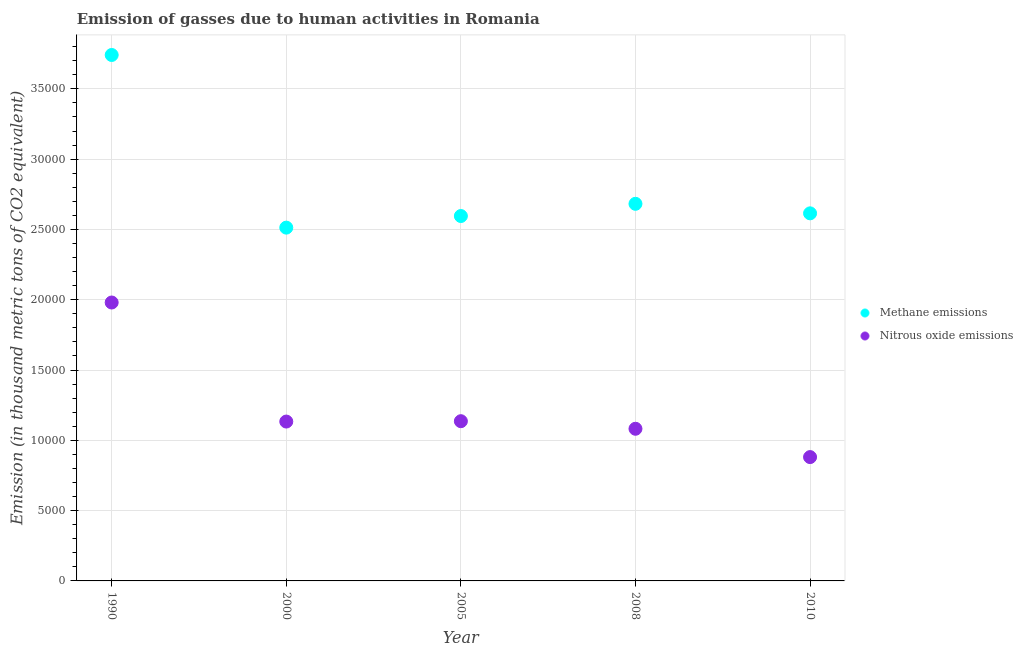Is the number of dotlines equal to the number of legend labels?
Offer a very short reply. Yes. What is the amount of methane emissions in 2010?
Your answer should be compact. 2.61e+04. Across all years, what is the maximum amount of methane emissions?
Provide a short and direct response. 3.74e+04. Across all years, what is the minimum amount of methane emissions?
Ensure brevity in your answer.  2.51e+04. In which year was the amount of nitrous oxide emissions maximum?
Provide a short and direct response. 1990. What is the total amount of nitrous oxide emissions in the graph?
Keep it short and to the point. 6.21e+04. What is the difference between the amount of methane emissions in 1990 and that in 2005?
Offer a very short reply. 1.15e+04. What is the difference between the amount of nitrous oxide emissions in 2010 and the amount of methane emissions in 2005?
Offer a very short reply. -1.71e+04. What is the average amount of nitrous oxide emissions per year?
Your answer should be compact. 1.24e+04. In the year 2000, what is the difference between the amount of methane emissions and amount of nitrous oxide emissions?
Provide a short and direct response. 1.38e+04. What is the ratio of the amount of methane emissions in 2005 to that in 2010?
Keep it short and to the point. 0.99. Is the difference between the amount of methane emissions in 2000 and 2005 greater than the difference between the amount of nitrous oxide emissions in 2000 and 2005?
Provide a succinct answer. No. What is the difference between the highest and the second highest amount of methane emissions?
Your answer should be compact. 1.06e+04. What is the difference between the highest and the lowest amount of methane emissions?
Ensure brevity in your answer.  1.23e+04. In how many years, is the amount of nitrous oxide emissions greater than the average amount of nitrous oxide emissions taken over all years?
Provide a short and direct response. 1. Is the amount of nitrous oxide emissions strictly less than the amount of methane emissions over the years?
Your answer should be very brief. Yes. How many years are there in the graph?
Your answer should be very brief. 5. What is the difference between two consecutive major ticks on the Y-axis?
Your answer should be very brief. 5000. Are the values on the major ticks of Y-axis written in scientific E-notation?
Keep it short and to the point. No. Does the graph contain any zero values?
Offer a terse response. No. Where does the legend appear in the graph?
Ensure brevity in your answer.  Center right. What is the title of the graph?
Your answer should be very brief. Emission of gasses due to human activities in Romania. Does "Public credit registry" appear as one of the legend labels in the graph?
Ensure brevity in your answer.  No. What is the label or title of the Y-axis?
Give a very brief answer. Emission (in thousand metric tons of CO2 equivalent). What is the Emission (in thousand metric tons of CO2 equivalent) of Methane emissions in 1990?
Your answer should be compact. 3.74e+04. What is the Emission (in thousand metric tons of CO2 equivalent) in Nitrous oxide emissions in 1990?
Offer a terse response. 1.98e+04. What is the Emission (in thousand metric tons of CO2 equivalent) of Methane emissions in 2000?
Make the answer very short. 2.51e+04. What is the Emission (in thousand metric tons of CO2 equivalent) in Nitrous oxide emissions in 2000?
Provide a succinct answer. 1.13e+04. What is the Emission (in thousand metric tons of CO2 equivalent) of Methane emissions in 2005?
Provide a short and direct response. 2.60e+04. What is the Emission (in thousand metric tons of CO2 equivalent) in Nitrous oxide emissions in 2005?
Give a very brief answer. 1.14e+04. What is the Emission (in thousand metric tons of CO2 equivalent) of Methane emissions in 2008?
Your answer should be very brief. 2.68e+04. What is the Emission (in thousand metric tons of CO2 equivalent) in Nitrous oxide emissions in 2008?
Offer a terse response. 1.08e+04. What is the Emission (in thousand metric tons of CO2 equivalent) in Methane emissions in 2010?
Your response must be concise. 2.61e+04. What is the Emission (in thousand metric tons of CO2 equivalent) in Nitrous oxide emissions in 2010?
Your answer should be very brief. 8808.3. Across all years, what is the maximum Emission (in thousand metric tons of CO2 equivalent) of Methane emissions?
Offer a terse response. 3.74e+04. Across all years, what is the maximum Emission (in thousand metric tons of CO2 equivalent) of Nitrous oxide emissions?
Give a very brief answer. 1.98e+04. Across all years, what is the minimum Emission (in thousand metric tons of CO2 equivalent) in Methane emissions?
Keep it short and to the point. 2.51e+04. Across all years, what is the minimum Emission (in thousand metric tons of CO2 equivalent) of Nitrous oxide emissions?
Provide a succinct answer. 8808.3. What is the total Emission (in thousand metric tons of CO2 equivalent) in Methane emissions in the graph?
Your response must be concise. 1.41e+05. What is the total Emission (in thousand metric tons of CO2 equivalent) in Nitrous oxide emissions in the graph?
Ensure brevity in your answer.  6.21e+04. What is the difference between the Emission (in thousand metric tons of CO2 equivalent) in Methane emissions in 1990 and that in 2000?
Ensure brevity in your answer.  1.23e+04. What is the difference between the Emission (in thousand metric tons of CO2 equivalent) in Nitrous oxide emissions in 1990 and that in 2000?
Keep it short and to the point. 8468. What is the difference between the Emission (in thousand metric tons of CO2 equivalent) in Methane emissions in 1990 and that in 2005?
Your answer should be very brief. 1.15e+04. What is the difference between the Emission (in thousand metric tons of CO2 equivalent) in Nitrous oxide emissions in 1990 and that in 2005?
Ensure brevity in your answer.  8442.4. What is the difference between the Emission (in thousand metric tons of CO2 equivalent) of Methane emissions in 1990 and that in 2008?
Offer a terse response. 1.06e+04. What is the difference between the Emission (in thousand metric tons of CO2 equivalent) of Nitrous oxide emissions in 1990 and that in 2008?
Ensure brevity in your answer.  8981.2. What is the difference between the Emission (in thousand metric tons of CO2 equivalent) in Methane emissions in 1990 and that in 2010?
Your answer should be compact. 1.13e+04. What is the difference between the Emission (in thousand metric tons of CO2 equivalent) in Nitrous oxide emissions in 1990 and that in 2010?
Make the answer very short. 1.10e+04. What is the difference between the Emission (in thousand metric tons of CO2 equivalent) in Methane emissions in 2000 and that in 2005?
Provide a short and direct response. -826. What is the difference between the Emission (in thousand metric tons of CO2 equivalent) in Nitrous oxide emissions in 2000 and that in 2005?
Give a very brief answer. -25.6. What is the difference between the Emission (in thousand metric tons of CO2 equivalent) of Methane emissions in 2000 and that in 2008?
Your response must be concise. -1694.4. What is the difference between the Emission (in thousand metric tons of CO2 equivalent) in Nitrous oxide emissions in 2000 and that in 2008?
Your answer should be very brief. 513.2. What is the difference between the Emission (in thousand metric tons of CO2 equivalent) in Methane emissions in 2000 and that in 2010?
Ensure brevity in your answer.  -1016.6. What is the difference between the Emission (in thousand metric tons of CO2 equivalent) in Nitrous oxide emissions in 2000 and that in 2010?
Provide a short and direct response. 2527.5. What is the difference between the Emission (in thousand metric tons of CO2 equivalent) in Methane emissions in 2005 and that in 2008?
Make the answer very short. -868.4. What is the difference between the Emission (in thousand metric tons of CO2 equivalent) of Nitrous oxide emissions in 2005 and that in 2008?
Your answer should be very brief. 538.8. What is the difference between the Emission (in thousand metric tons of CO2 equivalent) in Methane emissions in 2005 and that in 2010?
Provide a succinct answer. -190.6. What is the difference between the Emission (in thousand metric tons of CO2 equivalent) in Nitrous oxide emissions in 2005 and that in 2010?
Provide a short and direct response. 2553.1. What is the difference between the Emission (in thousand metric tons of CO2 equivalent) in Methane emissions in 2008 and that in 2010?
Provide a short and direct response. 677.8. What is the difference between the Emission (in thousand metric tons of CO2 equivalent) of Nitrous oxide emissions in 2008 and that in 2010?
Ensure brevity in your answer.  2014.3. What is the difference between the Emission (in thousand metric tons of CO2 equivalent) in Methane emissions in 1990 and the Emission (in thousand metric tons of CO2 equivalent) in Nitrous oxide emissions in 2000?
Make the answer very short. 2.61e+04. What is the difference between the Emission (in thousand metric tons of CO2 equivalent) of Methane emissions in 1990 and the Emission (in thousand metric tons of CO2 equivalent) of Nitrous oxide emissions in 2005?
Provide a succinct answer. 2.60e+04. What is the difference between the Emission (in thousand metric tons of CO2 equivalent) in Methane emissions in 1990 and the Emission (in thousand metric tons of CO2 equivalent) in Nitrous oxide emissions in 2008?
Provide a short and direct response. 2.66e+04. What is the difference between the Emission (in thousand metric tons of CO2 equivalent) of Methane emissions in 1990 and the Emission (in thousand metric tons of CO2 equivalent) of Nitrous oxide emissions in 2010?
Provide a short and direct response. 2.86e+04. What is the difference between the Emission (in thousand metric tons of CO2 equivalent) of Methane emissions in 2000 and the Emission (in thousand metric tons of CO2 equivalent) of Nitrous oxide emissions in 2005?
Provide a succinct answer. 1.38e+04. What is the difference between the Emission (in thousand metric tons of CO2 equivalent) of Methane emissions in 2000 and the Emission (in thousand metric tons of CO2 equivalent) of Nitrous oxide emissions in 2008?
Provide a short and direct response. 1.43e+04. What is the difference between the Emission (in thousand metric tons of CO2 equivalent) in Methane emissions in 2000 and the Emission (in thousand metric tons of CO2 equivalent) in Nitrous oxide emissions in 2010?
Give a very brief answer. 1.63e+04. What is the difference between the Emission (in thousand metric tons of CO2 equivalent) of Methane emissions in 2005 and the Emission (in thousand metric tons of CO2 equivalent) of Nitrous oxide emissions in 2008?
Your answer should be very brief. 1.51e+04. What is the difference between the Emission (in thousand metric tons of CO2 equivalent) in Methane emissions in 2005 and the Emission (in thousand metric tons of CO2 equivalent) in Nitrous oxide emissions in 2010?
Make the answer very short. 1.71e+04. What is the difference between the Emission (in thousand metric tons of CO2 equivalent) of Methane emissions in 2008 and the Emission (in thousand metric tons of CO2 equivalent) of Nitrous oxide emissions in 2010?
Keep it short and to the point. 1.80e+04. What is the average Emission (in thousand metric tons of CO2 equivalent) of Methane emissions per year?
Provide a short and direct response. 2.83e+04. What is the average Emission (in thousand metric tons of CO2 equivalent) in Nitrous oxide emissions per year?
Your answer should be very brief. 1.24e+04. In the year 1990, what is the difference between the Emission (in thousand metric tons of CO2 equivalent) in Methane emissions and Emission (in thousand metric tons of CO2 equivalent) in Nitrous oxide emissions?
Your answer should be compact. 1.76e+04. In the year 2000, what is the difference between the Emission (in thousand metric tons of CO2 equivalent) of Methane emissions and Emission (in thousand metric tons of CO2 equivalent) of Nitrous oxide emissions?
Provide a short and direct response. 1.38e+04. In the year 2005, what is the difference between the Emission (in thousand metric tons of CO2 equivalent) of Methane emissions and Emission (in thousand metric tons of CO2 equivalent) of Nitrous oxide emissions?
Offer a very short reply. 1.46e+04. In the year 2008, what is the difference between the Emission (in thousand metric tons of CO2 equivalent) of Methane emissions and Emission (in thousand metric tons of CO2 equivalent) of Nitrous oxide emissions?
Your answer should be compact. 1.60e+04. In the year 2010, what is the difference between the Emission (in thousand metric tons of CO2 equivalent) in Methane emissions and Emission (in thousand metric tons of CO2 equivalent) in Nitrous oxide emissions?
Your response must be concise. 1.73e+04. What is the ratio of the Emission (in thousand metric tons of CO2 equivalent) in Methane emissions in 1990 to that in 2000?
Your answer should be compact. 1.49. What is the ratio of the Emission (in thousand metric tons of CO2 equivalent) of Nitrous oxide emissions in 1990 to that in 2000?
Offer a terse response. 1.75. What is the ratio of the Emission (in thousand metric tons of CO2 equivalent) in Methane emissions in 1990 to that in 2005?
Keep it short and to the point. 1.44. What is the ratio of the Emission (in thousand metric tons of CO2 equivalent) of Nitrous oxide emissions in 1990 to that in 2005?
Offer a terse response. 1.74. What is the ratio of the Emission (in thousand metric tons of CO2 equivalent) in Methane emissions in 1990 to that in 2008?
Ensure brevity in your answer.  1.39. What is the ratio of the Emission (in thousand metric tons of CO2 equivalent) in Nitrous oxide emissions in 1990 to that in 2008?
Ensure brevity in your answer.  1.83. What is the ratio of the Emission (in thousand metric tons of CO2 equivalent) in Methane emissions in 1990 to that in 2010?
Ensure brevity in your answer.  1.43. What is the ratio of the Emission (in thousand metric tons of CO2 equivalent) in Nitrous oxide emissions in 1990 to that in 2010?
Give a very brief answer. 2.25. What is the ratio of the Emission (in thousand metric tons of CO2 equivalent) of Methane emissions in 2000 to that in 2005?
Give a very brief answer. 0.97. What is the ratio of the Emission (in thousand metric tons of CO2 equivalent) in Methane emissions in 2000 to that in 2008?
Ensure brevity in your answer.  0.94. What is the ratio of the Emission (in thousand metric tons of CO2 equivalent) of Nitrous oxide emissions in 2000 to that in 2008?
Provide a short and direct response. 1.05. What is the ratio of the Emission (in thousand metric tons of CO2 equivalent) in Methane emissions in 2000 to that in 2010?
Offer a very short reply. 0.96. What is the ratio of the Emission (in thousand metric tons of CO2 equivalent) in Nitrous oxide emissions in 2000 to that in 2010?
Offer a terse response. 1.29. What is the ratio of the Emission (in thousand metric tons of CO2 equivalent) in Methane emissions in 2005 to that in 2008?
Provide a short and direct response. 0.97. What is the ratio of the Emission (in thousand metric tons of CO2 equivalent) in Nitrous oxide emissions in 2005 to that in 2008?
Ensure brevity in your answer.  1.05. What is the ratio of the Emission (in thousand metric tons of CO2 equivalent) of Nitrous oxide emissions in 2005 to that in 2010?
Keep it short and to the point. 1.29. What is the ratio of the Emission (in thousand metric tons of CO2 equivalent) in Methane emissions in 2008 to that in 2010?
Keep it short and to the point. 1.03. What is the ratio of the Emission (in thousand metric tons of CO2 equivalent) in Nitrous oxide emissions in 2008 to that in 2010?
Keep it short and to the point. 1.23. What is the difference between the highest and the second highest Emission (in thousand metric tons of CO2 equivalent) in Methane emissions?
Your answer should be compact. 1.06e+04. What is the difference between the highest and the second highest Emission (in thousand metric tons of CO2 equivalent) of Nitrous oxide emissions?
Your answer should be compact. 8442.4. What is the difference between the highest and the lowest Emission (in thousand metric tons of CO2 equivalent) in Methane emissions?
Offer a very short reply. 1.23e+04. What is the difference between the highest and the lowest Emission (in thousand metric tons of CO2 equivalent) of Nitrous oxide emissions?
Your answer should be compact. 1.10e+04. 